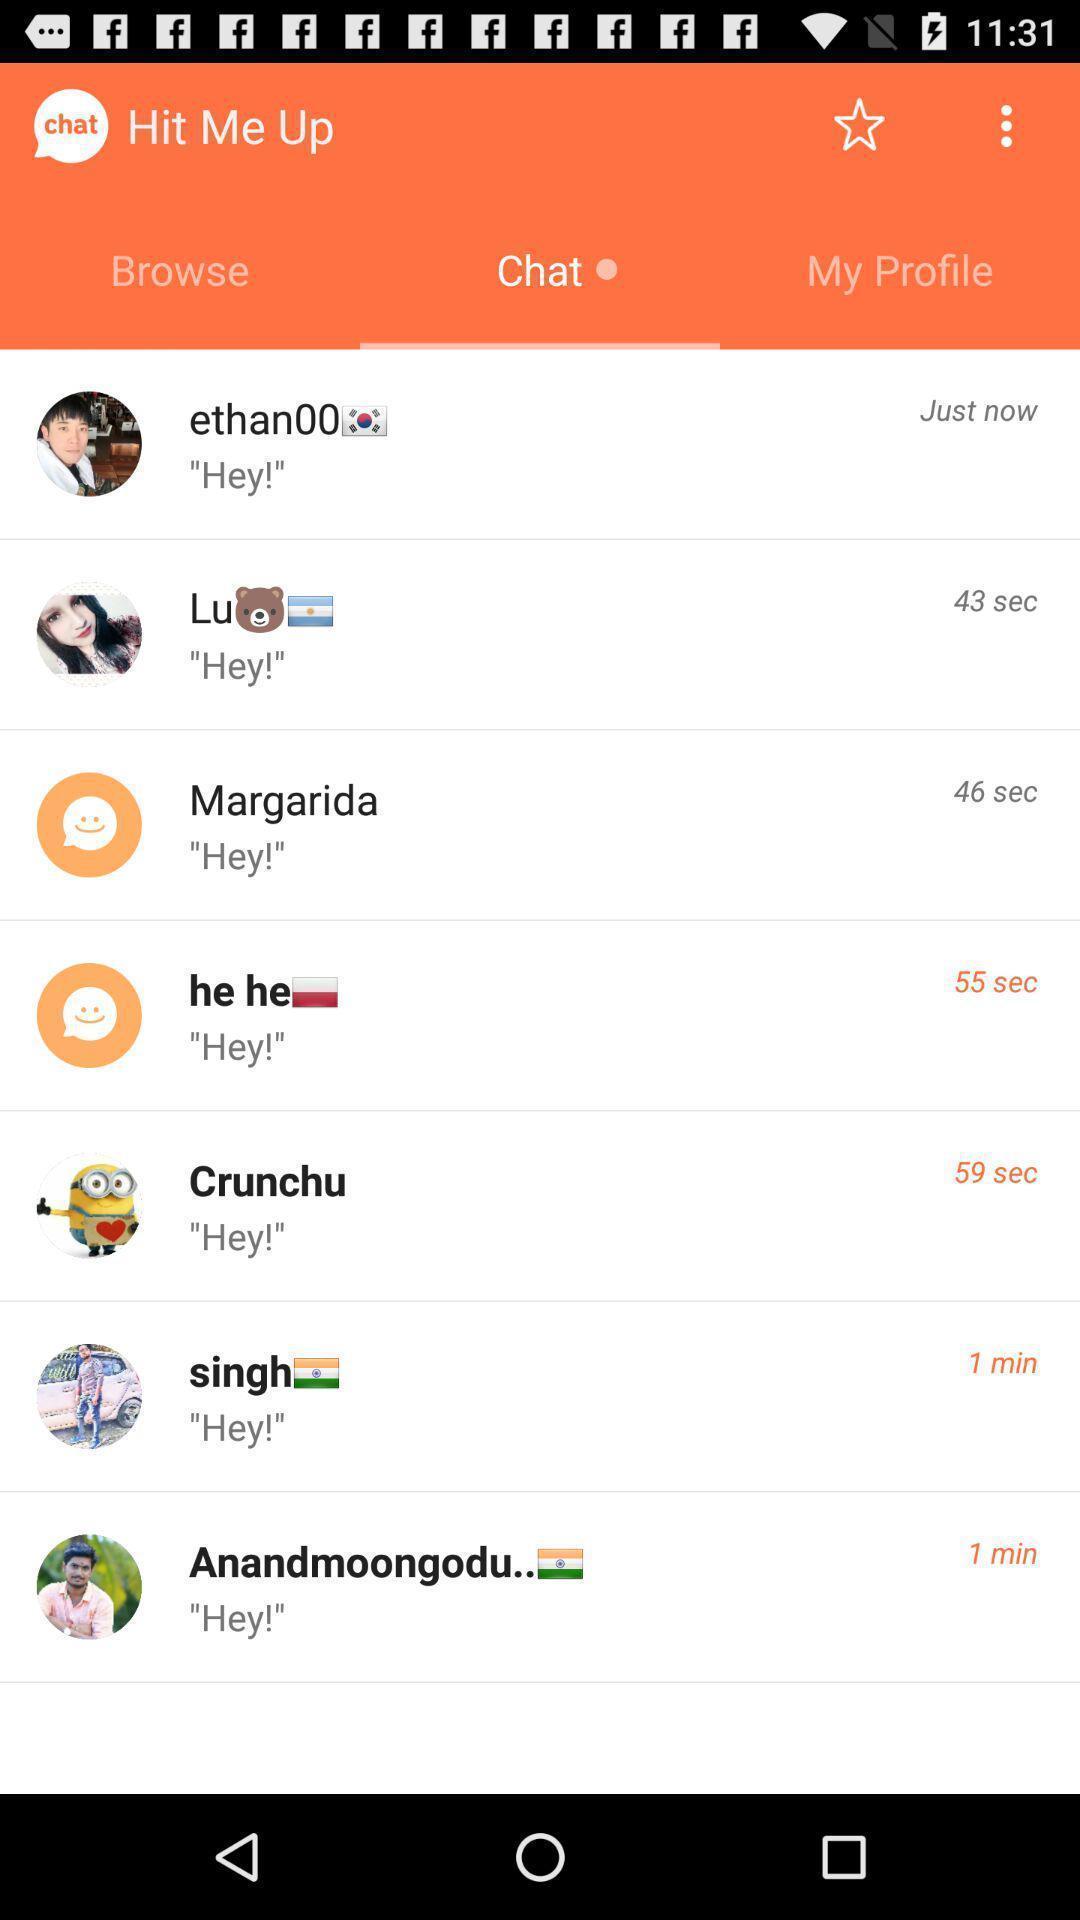Describe the visual elements of this screenshot. Page showing chat 's. 